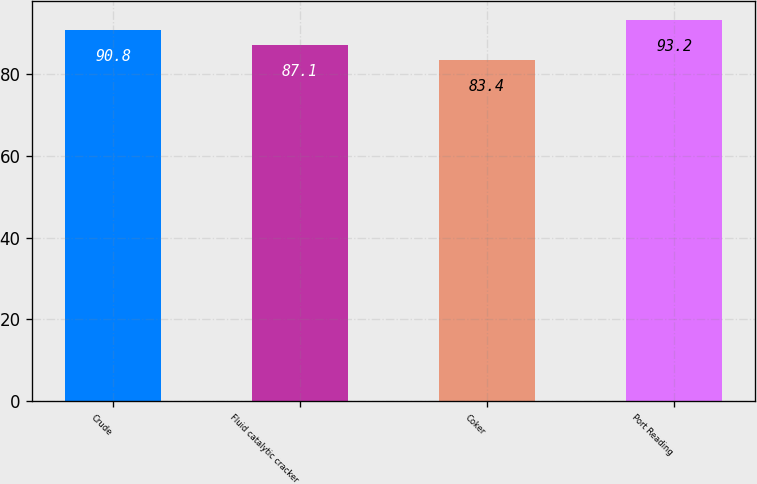<chart> <loc_0><loc_0><loc_500><loc_500><bar_chart><fcel>Crude<fcel>Fluid catalytic cracker<fcel>Coker<fcel>Port Reading<nl><fcel>90.8<fcel>87.1<fcel>83.4<fcel>93.2<nl></chart> 